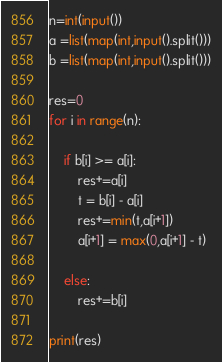<code> <loc_0><loc_0><loc_500><loc_500><_Python_>n=int(input())
a =list(map(int,input().split()))
b =list(map(int,input().split()))

res=0
for i in range(n):

    if b[i] >= a[i]:
        res+=a[i]
        t = b[i] - a[i]
        res+=min(t,a[i+1])
        a[i+1] = max(0,a[i+1] - t)

    else:
        res+=b[i]

print(res)</code> 